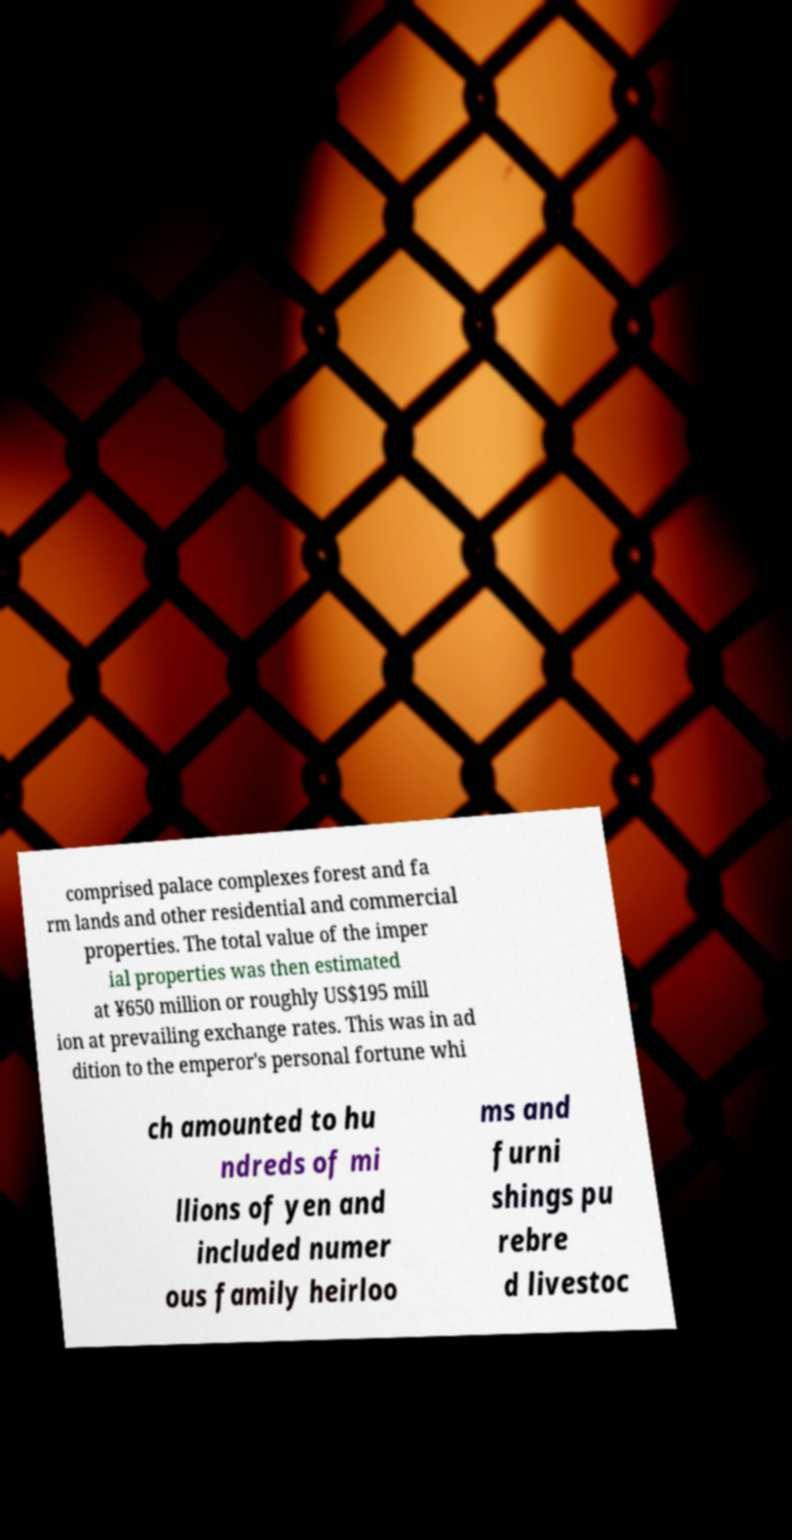Please identify and transcribe the text found in this image. comprised palace complexes forest and fa rm lands and other residential and commercial properties. The total value of the imper ial properties was then estimated at ¥650 million or roughly US$195 mill ion at prevailing exchange rates. This was in ad dition to the emperor's personal fortune whi ch amounted to hu ndreds of mi llions of yen and included numer ous family heirloo ms and furni shings pu rebre d livestoc 